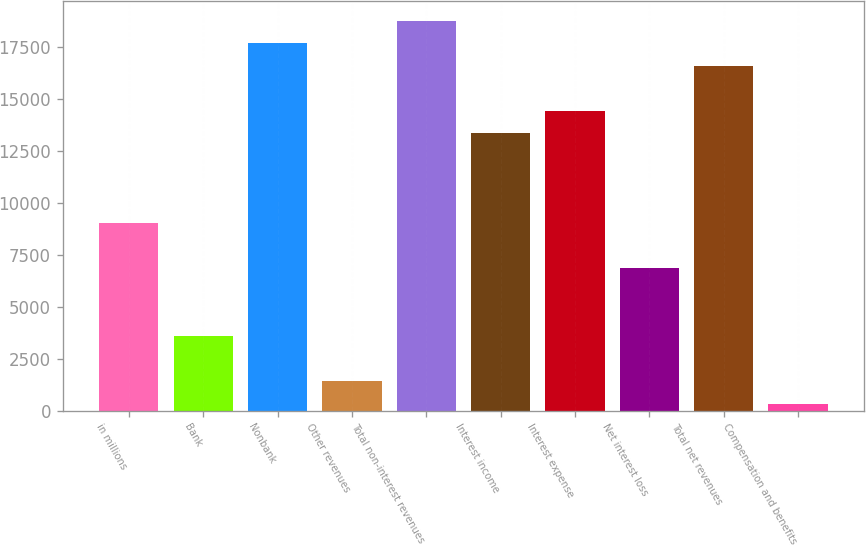<chart> <loc_0><loc_0><loc_500><loc_500><bar_chart><fcel>in millions<fcel>Bank<fcel>Nonbank<fcel>Other revenues<fcel>Total non-interest revenues<fcel>Interest income<fcel>Interest expense<fcel>Net interest loss<fcel>Total net revenues<fcel>Compensation and benefits<nl><fcel>9011.6<fcel>3585.6<fcel>17693.2<fcel>1415.2<fcel>18778.4<fcel>13352.4<fcel>14437.6<fcel>6841.2<fcel>16608<fcel>330<nl></chart> 